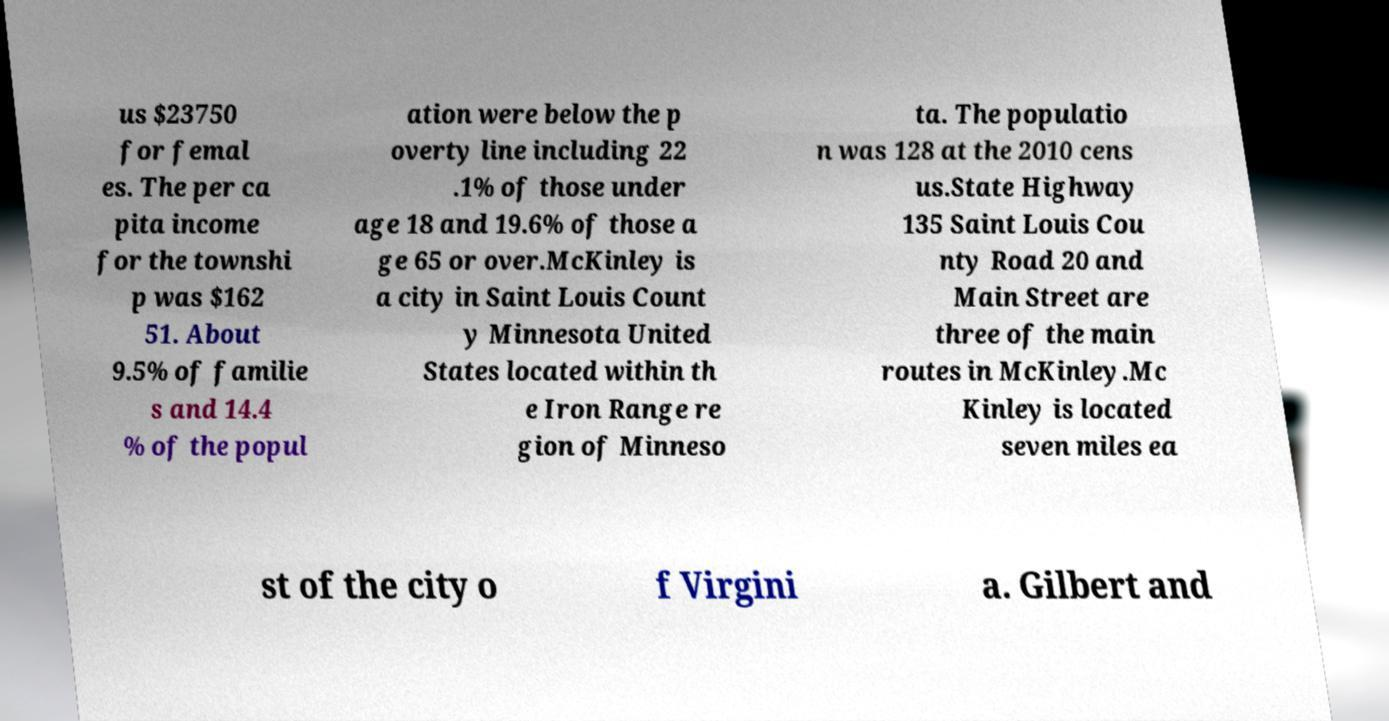What messages or text are displayed in this image? I need them in a readable, typed format. us $23750 for femal es. The per ca pita income for the townshi p was $162 51. About 9.5% of familie s and 14.4 % of the popul ation were below the p overty line including 22 .1% of those under age 18 and 19.6% of those a ge 65 or over.McKinley is a city in Saint Louis Count y Minnesota United States located within th e Iron Range re gion of Minneso ta. The populatio n was 128 at the 2010 cens us.State Highway 135 Saint Louis Cou nty Road 20 and Main Street are three of the main routes in McKinley.Mc Kinley is located seven miles ea st of the city o f Virgini a. Gilbert and 